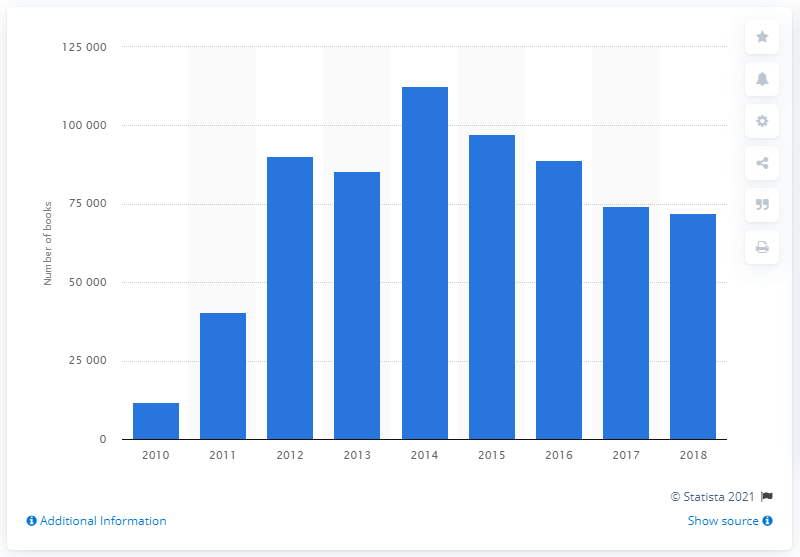List a handful of essential elements in this visual. Smashwords published 71,969 books in 2018. Smashwords published 74,290 books in 2017. 